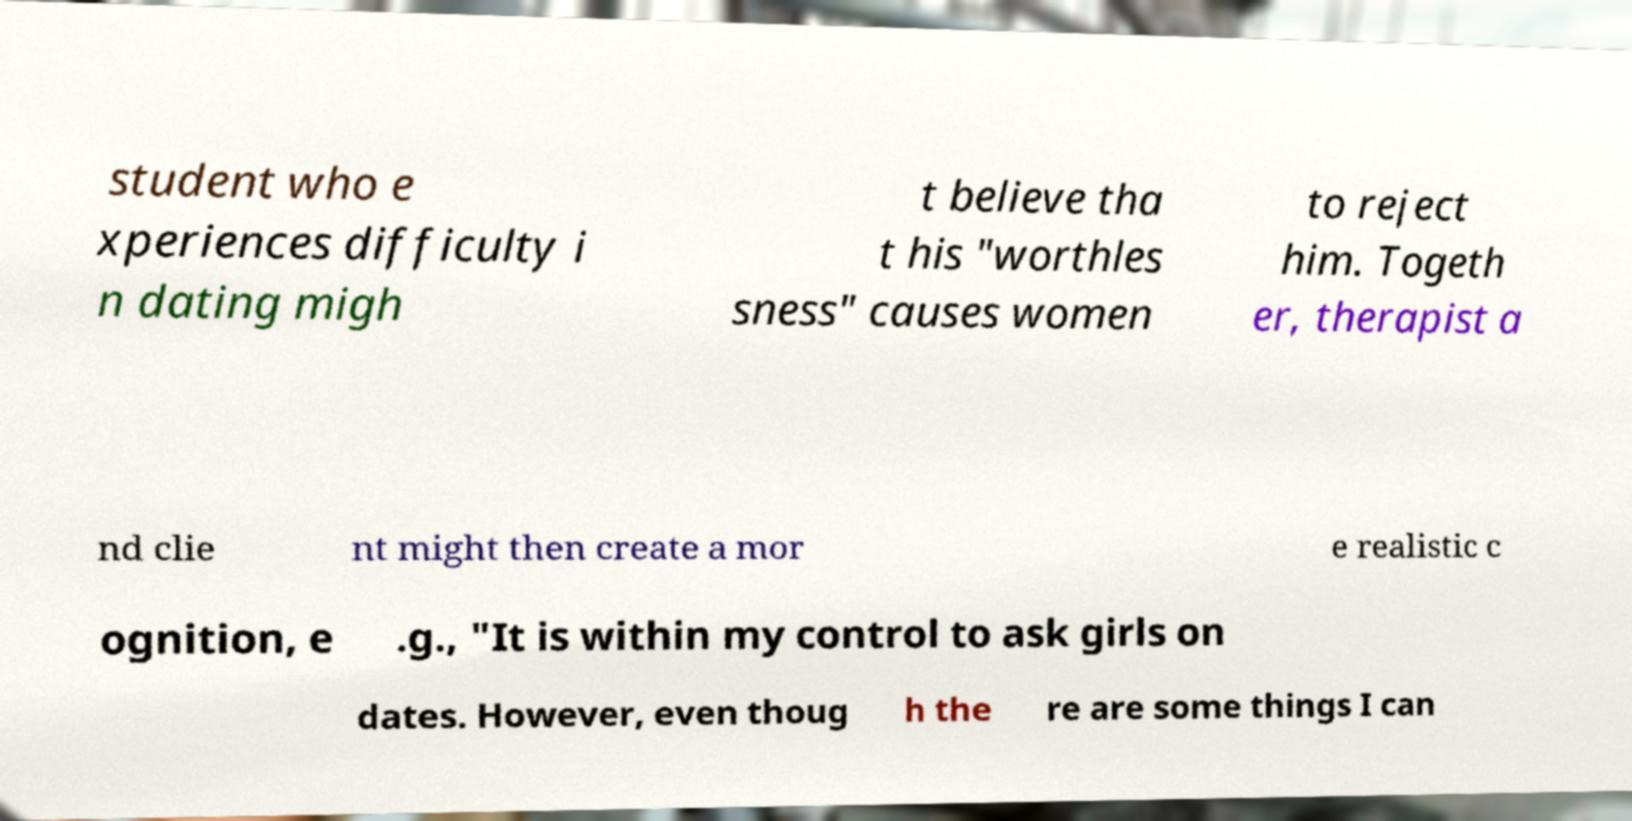There's text embedded in this image that I need extracted. Can you transcribe it verbatim? student who e xperiences difficulty i n dating migh t believe tha t his "worthles sness" causes women to reject him. Togeth er, therapist a nd clie nt might then create a mor e realistic c ognition, e .g., "It is within my control to ask girls on dates. However, even thoug h the re are some things I can 